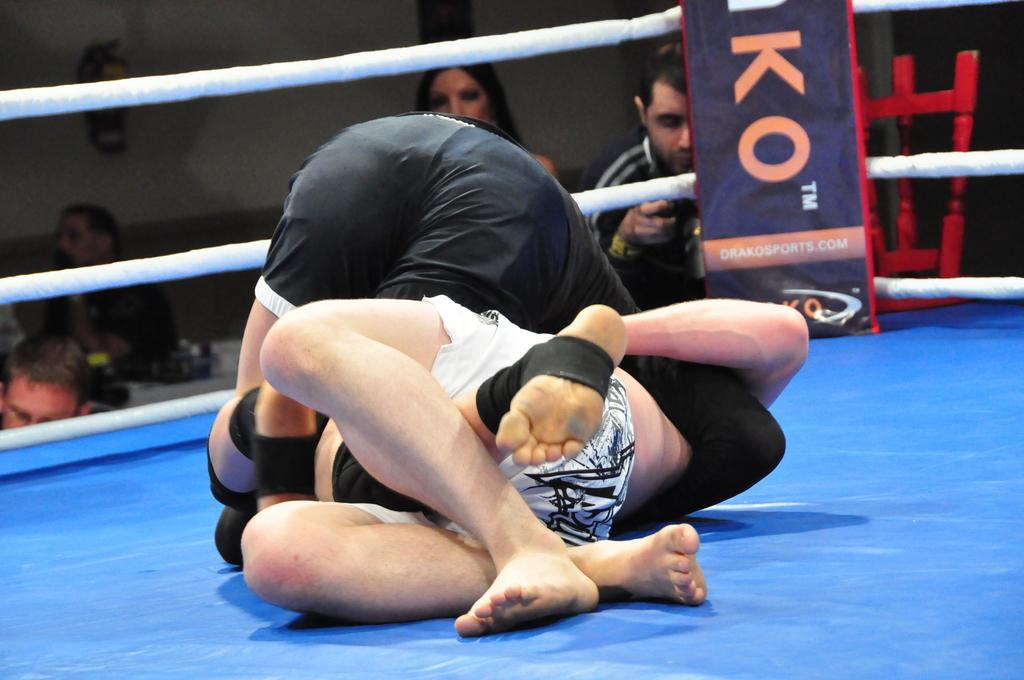Provide a one-sentence caption for the provided image. Two wrestlers on a blue mat with the letter KO behind them. 